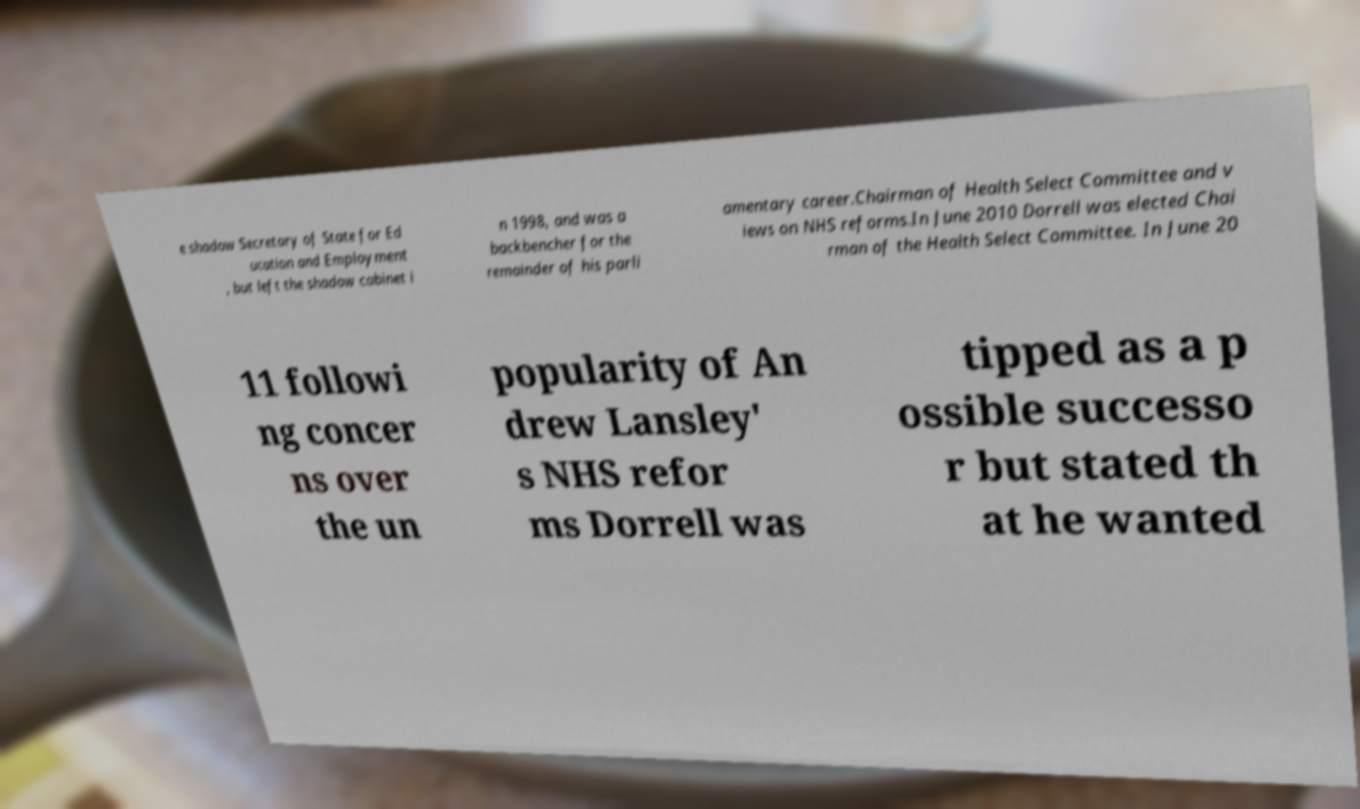Can you accurately transcribe the text from the provided image for me? e shadow Secretary of State for Ed ucation and Employment , but left the shadow cabinet i n 1998, and was a backbencher for the remainder of his parli amentary career.Chairman of Health Select Committee and v iews on NHS reforms.In June 2010 Dorrell was elected Chai rman of the Health Select Committee. In June 20 11 followi ng concer ns over the un popularity of An drew Lansley' s NHS refor ms Dorrell was tipped as a p ossible successo r but stated th at he wanted 